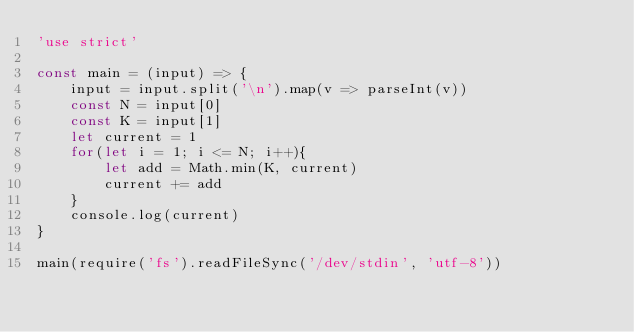Convert code to text. <code><loc_0><loc_0><loc_500><loc_500><_JavaScript_>'use strict'

const main = (input) => {
    input = input.split('\n').map(v => parseInt(v))
    const N = input[0]
    const K = input[1]
    let current = 1
    for(let i = 1; i <= N; i++){
        let add = Math.min(K, current) 
        current += add
    }
    console.log(current)
}

main(require('fs').readFileSync('/dev/stdin', 'utf-8'))</code> 